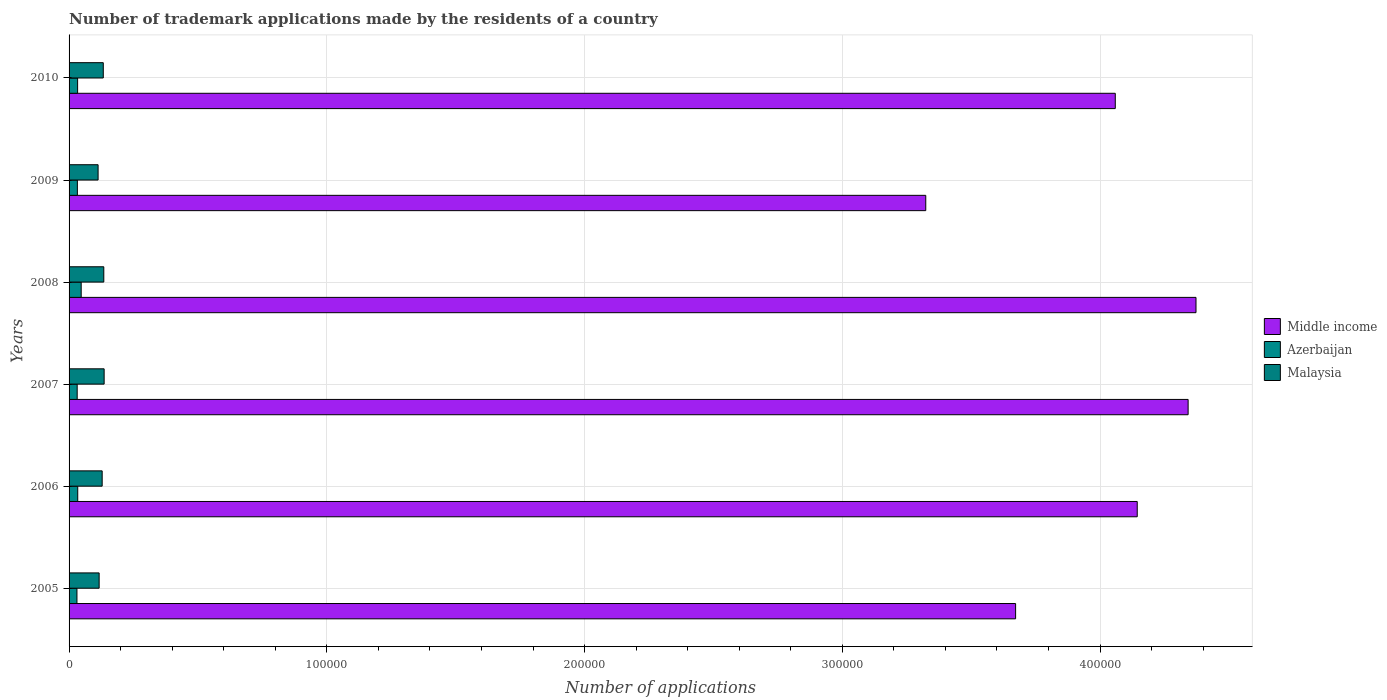How many different coloured bars are there?
Your answer should be very brief. 3. Are the number of bars per tick equal to the number of legend labels?
Ensure brevity in your answer.  Yes. How many bars are there on the 6th tick from the top?
Ensure brevity in your answer.  3. How many bars are there on the 2nd tick from the bottom?
Your response must be concise. 3. What is the label of the 1st group of bars from the top?
Keep it short and to the point. 2010. In how many cases, is the number of bars for a given year not equal to the number of legend labels?
Your answer should be very brief. 0. What is the number of trademark applications made by the residents in Middle income in 2010?
Offer a terse response. 4.06e+05. Across all years, what is the maximum number of trademark applications made by the residents in Middle income?
Keep it short and to the point. 4.37e+05. Across all years, what is the minimum number of trademark applications made by the residents in Middle income?
Your answer should be very brief. 3.32e+05. In which year was the number of trademark applications made by the residents in Middle income maximum?
Keep it short and to the point. 2008. What is the total number of trademark applications made by the residents in Middle income in the graph?
Your answer should be compact. 2.39e+06. What is the difference between the number of trademark applications made by the residents in Malaysia in 2005 and that in 2006?
Provide a succinct answer. -1172. What is the difference between the number of trademark applications made by the residents in Azerbaijan in 2005 and the number of trademark applications made by the residents in Malaysia in 2008?
Provide a succinct answer. -1.04e+04. What is the average number of trademark applications made by the residents in Malaysia per year?
Offer a very short reply. 1.27e+04. In the year 2008, what is the difference between the number of trademark applications made by the residents in Malaysia and number of trademark applications made by the residents in Azerbaijan?
Provide a short and direct response. 8771. What is the ratio of the number of trademark applications made by the residents in Middle income in 2005 to that in 2010?
Provide a short and direct response. 0.9. Is the difference between the number of trademark applications made by the residents in Malaysia in 2007 and 2010 greater than the difference between the number of trademark applications made by the residents in Azerbaijan in 2007 and 2010?
Provide a short and direct response. Yes. What is the difference between the highest and the second highest number of trademark applications made by the residents in Azerbaijan?
Give a very brief answer. 1338. What is the difference between the highest and the lowest number of trademark applications made by the residents in Malaysia?
Your answer should be compact. 2345. In how many years, is the number of trademark applications made by the residents in Azerbaijan greater than the average number of trademark applications made by the residents in Azerbaijan taken over all years?
Provide a succinct answer. 1. What does the 1st bar from the top in 2009 represents?
Provide a succinct answer. Malaysia. What does the 3rd bar from the bottom in 2007 represents?
Provide a succinct answer. Malaysia. How many bars are there?
Offer a very short reply. 18. Are all the bars in the graph horizontal?
Offer a terse response. Yes. Where does the legend appear in the graph?
Your answer should be compact. Center right. What is the title of the graph?
Provide a short and direct response. Number of trademark applications made by the residents of a country. What is the label or title of the X-axis?
Ensure brevity in your answer.  Number of applications. What is the Number of applications in Middle income in 2005?
Your response must be concise. 3.67e+05. What is the Number of applications of Azerbaijan in 2005?
Offer a terse response. 3061. What is the Number of applications in Malaysia in 2005?
Offer a terse response. 1.17e+04. What is the Number of applications of Middle income in 2006?
Make the answer very short. 4.14e+05. What is the Number of applications of Azerbaijan in 2006?
Offer a terse response. 3363. What is the Number of applications of Malaysia in 2006?
Provide a succinct answer. 1.28e+04. What is the Number of applications of Middle income in 2007?
Give a very brief answer. 4.34e+05. What is the Number of applications in Azerbaijan in 2007?
Ensure brevity in your answer.  3149. What is the Number of applications in Malaysia in 2007?
Your answer should be compact. 1.36e+04. What is the Number of applications in Middle income in 2008?
Ensure brevity in your answer.  4.37e+05. What is the Number of applications in Azerbaijan in 2008?
Give a very brief answer. 4701. What is the Number of applications in Malaysia in 2008?
Your response must be concise. 1.35e+04. What is the Number of applications in Middle income in 2009?
Offer a very short reply. 3.32e+05. What is the Number of applications of Azerbaijan in 2009?
Provide a succinct answer. 3221. What is the Number of applications in Malaysia in 2009?
Ensure brevity in your answer.  1.13e+04. What is the Number of applications of Middle income in 2010?
Offer a very short reply. 4.06e+05. What is the Number of applications in Azerbaijan in 2010?
Ensure brevity in your answer.  3310. What is the Number of applications in Malaysia in 2010?
Offer a very short reply. 1.33e+04. Across all years, what is the maximum Number of applications of Middle income?
Offer a very short reply. 4.37e+05. Across all years, what is the maximum Number of applications in Azerbaijan?
Give a very brief answer. 4701. Across all years, what is the maximum Number of applications in Malaysia?
Ensure brevity in your answer.  1.36e+04. Across all years, what is the minimum Number of applications in Middle income?
Offer a very short reply. 3.32e+05. Across all years, what is the minimum Number of applications of Azerbaijan?
Provide a short and direct response. 3061. Across all years, what is the minimum Number of applications in Malaysia?
Your answer should be compact. 1.13e+04. What is the total Number of applications in Middle income in the graph?
Your response must be concise. 2.39e+06. What is the total Number of applications in Azerbaijan in the graph?
Offer a terse response. 2.08e+04. What is the total Number of applications of Malaysia in the graph?
Provide a succinct answer. 7.61e+04. What is the difference between the Number of applications in Middle income in 2005 and that in 2006?
Ensure brevity in your answer.  -4.72e+04. What is the difference between the Number of applications in Azerbaijan in 2005 and that in 2006?
Your response must be concise. -302. What is the difference between the Number of applications of Malaysia in 2005 and that in 2006?
Offer a terse response. -1172. What is the difference between the Number of applications of Middle income in 2005 and that in 2007?
Keep it short and to the point. -6.69e+04. What is the difference between the Number of applications in Azerbaijan in 2005 and that in 2007?
Make the answer very short. -88. What is the difference between the Number of applications in Malaysia in 2005 and that in 2007?
Provide a short and direct response. -1937. What is the difference between the Number of applications in Middle income in 2005 and that in 2008?
Provide a short and direct response. -7.00e+04. What is the difference between the Number of applications of Azerbaijan in 2005 and that in 2008?
Keep it short and to the point. -1640. What is the difference between the Number of applications of Malaysia in 2005 and that in 2008?
Provide a succinct answer. -1804. What is the difference between the Number of applications of Middle income in 2005 and that in 2009?
Offer a very short reply. 3.49e+04. What is the difference between the Number of applications in Azerbaijan in 2005 and that in 2009?
Provide a short and direct response. -160. What is the difference between the Number of applications in Malaysia in 2005 and that in 2009?
Your answer should be compact. 408. What is the difference between the Number of applications in Middle income in 2005 and that in 2010?
Make the answer very short. -3.87e+04. What is the difference between the Number of applications in Azerbaijan in 2005 and that in 2010?
Make the answer very short. -249. What is the difference between the Number of applications of Malaysia in 2005 and that in 2010?
Make the answer very short. -1603. What is the difference between the Number of applications of Middle income in 2006 and that in 2007?
Provide a succinct answer. -1.97e+04. What is the difference between the Number of applications of Azerbaijan in 2006 and that in 2007?
Your answer should be compact. 214. What is the difference between the Number of applications of Malaysia in 2006 and that in 2007?
Provide a short and direct response. -765. What is the difference between the Number of applications in Middle income in 2006 and that in 2008?
Provide a succinct answer. -2.28e+04. What is the difference between the Number of applications in Azerbaijan in 2006 and that in 2008?
Provide a succinct answer. -1338. What is the difference between the Number of applications in Malaysia in 2006 and that in 2008?
Ensure brevity in your answer.  -632. What is the difference between the Number of applications in Middle income in 2006 and that in 2009?
Provide a succinct answer. 8.20e+04. What is the difference between the Number of applications of Azerbaijan in 2006 and that in 2009?
Make the answer very short. 142. What is the difference between the Number of applications in Malaysia in 2006 and that in 2009?
Offer a terse response. 1580. What is the difference between the Number of applications in Middle income in 2006 and that in 2010?
Ensure brevity in your answer.  8517. What is the difference between the Number of applications of Malaysia in 2006 and that in 2010?
Offer a very short reply. -431. What is the difference between the Number of applications in Middle income in 2007 and that in 2008?
Provide a short and direct response. -3058. What is the difference between the Number of applications of Azerbaijan in 2007 and that in 2008?
Your answer should be very brief. -1552. What is the difference between the Number of applications in Malaysia in 2007 and that in 2008?
Your answer should be compact. 133. What is the difference between the Number of applications in Middle income in 2007 and that in 2009?
Ensure brevity in your answer.  1.02e+05. What is the difference between the Number of applications in Azerbaijan in 2007 and that in 2009?
Ensure brevity in your answer.  -72. What is the difference between the Number of applications in Malaysia in 2007 and that in 2009?
Offer a very short reply. 2345. What is the difference between the Number of applications of Middle income in 2007 and that in 2010?
Provide a short and direct response. 2.83e+04. What is the difference between the Number of applications of Azerbaijan in 2007 and that in 2010?
Your answer should be compact. -161. What is the difference between the Number of applications in Malaysia in 2007 and that in 2010?
Make the answer very short. 334. What is the difference between the Number of applications in Middle income in 2008 and that in 2009?
Make the answer very short. 1.05e+05. What is the difference between the Number of applications in Azerbaijan in 2008 and that in 2009?
Provide a short and direct response. 1480. What is the difference between the Number of applications of Malaysia in 2008 and that in 2009?
Give a very brief answer. 2212. What is the difference between the Number of applications of Middle income in 2008 and that in 2010?
Your answer should be compact. 3.13e+04. What is the difference between the Number of applications of Azerbaijan in 2008 and that in 2010?
Make the answer very short. 1391. What is the difference between the Number of applications in Malaysia in 2008 and that in 2010?
Offer a terse response. 201. What is the difference between the Number of applications in Middle income in 2009 and that in 2010?
Provide a succinct answer. -7.35e+04. What is the difference between the Number of applications in Azerbaijan in 2009 and that in 2010?
Keep it short and to the point. -89. What is the difference between the Number of applications of Malaysia in 2009 and that in 2010?
Your response must be concise. -2011. What is the difference between the Number of applications of Middle income in 2005 and the Number of applications of Azerbaijan in 2006?
Keep it short and to the point. 3.64e+05. What is the difference between the Number of applications of Middle income in 2005 and the Number of applications of Malaysia in 2006?
Give a very brief answer. 3.54e+05. What is the difference between the Number of applications of Azerbaijan in 2005 and the Number of applications of Malaysia in 2006?
Your answer should be compact. -9779. What is the difference between the Number of applications of Middle income in 2005 and the Number of applications of Azerbaijan in 2007?
Provide a short and direct response. 3.64e+05. What is the difference between the Number of applications in Middle income in 2005 and the Number of applications in Malaysia in 2007?
Your answer should be very brief. 3.54e+05. What is the difference between the Number of applications of Azerbaijan in 2005 and the Number of applications of Malaysia in 2007?
Give a very brief answer. -1.05e+04. What is the difference between the Number of applications of Middle income in 2005 and the Number of applications of Azerbaijan in 2008?
Make the answer very short. 3.63e+05. What is the difference between the Number of applications in Middle income in 2005 and the Number of applications in Malaysia in 2008?
Make the answer very short. 3.54e+05. What is the difference between the Number of applications in Azerbaijan in 2005 and the Number of applications in Malaysia in 2008?
Your response must be concise. -1.04e+04. What is the difference between the Number of applications in Middle income in 2005 and the Number of applications in Azerbaijan in 2009?
Your response must be concise. 3.64e+05. What is the difference between the Number of applications in Middle income in 2005 and the Number of applications in Malaysia in 2009?
Your answer should be very brief. 3.56e+05. What is the difference between the Number of applications in Azerbaijan in 2005 and the Number of applications in Malaysia in 2009?
Keep it short and to the point. -8199. What is the difference between the Number of applications in Middle income in 2005 and the Number of applications in Azerbaijan in 2010?
Ensure brevity in your answer.  3.64e+05. What is the difference between the Number of applications of Middle income in 2005 and the Number of applications of Malaysia in 2010?
Ensure brevity in your answer.  3.54e+05. What is the difference between the Number of applications of Azerbaijan in 2005 and the Number of applications of Malaysia in 2010?
Make the answer very short. -1.02e+04. What is the difference between the Number of applications in Middle income in 2006 and the Number of applications in Azerbaijan in 2007?
Provide a short and direct response. 4.11e+05. What is the difference between the Number of applications of Middle income in 2006 and the Number of applications of Malaysia in 2007?
Provide a succinct answer. 4.01e+05. What is the difference between the Number of applications in Azerbaijan in 2006 and the Number of applications in Malaysia in 2007?
Your answer should be very brief. -1.02e+04. What is the difference between the Number of applications of Middle income in 2006 and the Number of applications of Azerbaijan in 2008?
Provide a succinct answer. 4.10e+05. What is the difference between the Number of applications of Middle income in 2006 and the Number of applications of Malaysia in 2008?
Make the answer very short. 4.01e+05. What is the difference between the Number of applications of Azerbaijan in 2006 and the Number of applications of Malaysia in 2008?
Keep it short and to the point. -1.01e+04. What is the difference between the Number of applications in Middle income in 2006 and the Number of applications in Azerbaijan in 2009?
Provide a succinct answer. 4.11e+05. What is the difference between the Number of applications in Middle income in 2006 and the Number of applications in Malaysia in 2009?
Offer a very short reply. 4.03e+05. What is the difference between the Number of applications in Azerbaijan in 2006 and the Number of applications in Malaysia in 2009?
Make the answer very short. -7897. What is the difference between the Number of applications of Middle income in 2006 and the Number of applications of Azerbaijan in 2010?
Provide a short and direct response. 4.11e+05. What is the difference between the Number of applications of Middle income in 2006 and the Number of applications of Malaysia in 2010?
Make the answer very short. 4.01e+05. What is the difference between the Number of applications in Azerbaijan in 2006 and the Number of applications in Malaysia in 2010?
Keep it short and to the point. -9908. What is the difference between the Number of applications of Middle income in 2007 and the Number of applications of Azerbaijan in 2008?
Provide a succinct answer. 4.29e+05. What is the difference between the Number of applications of Middle income in 2007 and the Number of applications of Malaysia in 2008?
Give a very brief answer. 4.21e+05. What is the difference between the Number of applications of Azerbaijan in 2007 and the Number of applications of Malaysia in 2008?
Ensure brevity in your answer.  -1.03e+04. What is the difference between the Number of applications of Middle income in 2007 and the Number of applications of Azerbaijan in 2009?
Give a very brief answer. 4.31e+05. What is the difference between the Number of applications in Middle income in 2007 and the Number of applications in Malaysia in 2009?
Provide a short and direct response. 4.23e+05. What is the difference between the Number of applications of Azerbaijan in 2007 and the Number of applications of Malaysia in 2009?
Offer a very short reply. -8111. What is the difference between the Number of applications in Middle income in 2007 and the Number of applications in Azerbaijan in 2010?
Keep it short and to the point. 4.31e+05. What is the difference between the Number of applications of Middle income in 2007 and the Number of applications of Malaysia in 2010?
Keep it short and to the point. 4.21e+05. What is the difference between the Number of applications in Azerbaijan in 2007 and the Number of applications in Malaysia in 2010?
Provide a succinct answer. -1.01e+04. What is the difference between the Number of applications of Middle income in 2008 and the Number of applications of Azerbaijan in 2009?
Your response must be concise. 4.34e+05. What is the difference between the Number of applications in Middle income in 2008 and the Number of applications in Malaysia in 2009?
Your answer should be compact. 4.26e+05. What is the difference between the Number of applications of Azerbaijan in 2008 and the Number of applications of Malaysia in 2009?
Your answer should be very brief. -6559. What is the difference between the Number of applications in Middle income in 2008 and the Number of applications in Azerbaijan in 2010?
Provide a short and direct response. 4.34e+05. What is the difference between the Number of applications in Middle income in 2008 and the Number of applications in Malaysia in 2010?
Offer a very short reply. 4.24e+05. What is the difference between the Number of applications in Azerbaijan in 2008 and the Number of applications in Malaysia in 2010?
Give a very brief answer. -8570. What is the difference between the Number of applications in Middle income in 2009 and the Number of applications in Azerbaijan in 2010?
Offer a terse response. 3.29e+05. What is the difference between the Number of applications of Middle income in 2009 and the Number of applications of Malaysia in 2010?
Give a very brief answer. 3.19e+05. What is the difference between the Number of applications of Azerbaijan in 2009 and the Number of applications of Malaysia in 2010?
Offer a terse response. -1.00e+04. What is the average Number of applications in Middle income per year?
Keep it short and to the point. 3.99e+05. What is the average Number of applications of Azerbaijan per year?
Your answer should be compact. 3467.5. What is the average Number of applications of Malaysia per year?
Give a very brief answer. 1.27e+04. In the year 2005, what is the difference between the Number of applications of Middle income and Number of applications of Azerbaijan?
Your response must be concise. 3.64e+05. In the year 2005, what is the difference between the Number of applications of Middle income and Number of applications of Malaysia?
Offer a terse response. 3.56e+05. In the year 2005, what is the difference between the Number of applications in Azerbaijan and Number of applications in Malaysia?
Provide a succinct answer. -8607. In the year 2006, what is the difference between the Number of applications of Middle income and Number of applications of Azerbaijan?
Ensure brevity in your answer.  4.11e+05. In the year 2006, what is the difference between the Number of applications of Middle income and Number of applications of Malaysia?
Provide a succinct answer. 4.02e+05. In the year 2006, what is the difference between the Number of applications in Azerbaijan and Number of applications in Malaysia?
Your answer should be compact. -9477. In the year 2007, what is the difference between the Number of applications of Middle income and Number of applications of Azerbaijan?
Ensure brevity in your answer.  4.31e+05. In the year 2007, what is the difference between the Number of applications in Middle income and Number of applications in Malaysia?
Provide a succinct answer. 4.21e+05. In the year 2007, what is the difference between the Number of applications of Azerbaijan and Number of applications of Malaysia?
Give a very brief answer. -1.05e+04. In the year 2008, what is the difference between the Number of applications of Middle income and Number of applications of Azerbaijan?
Your response must be concise. 4.33e+05. In the year 2008, what is the difference between the Number of applications in Middle income and Number of applications in Malaysia?
Ensure brevity in your answer.  4.24e+05. In the year 2008, what is the difference between the Number of applications of Azerbaijan and Number of applications of Malaysia?
Ensure brevity in your answer.  -8771. In the year 2009, what is the difference between the Number of applications of Middle income and Number of applications of Azerbaijan?
Keep it short and to the point. 3.29e+05. In the year 2009, what is the difference between the Number of applications in Middle income and Number of applications in Malaysia?
Ensure brevity in your answer.  3.21e+05. In the year 2009, what is the difference between the Number of applications in Azerbaijan and Number of applications in Malaysia?
Keep it short and to the point. -8039. In the year 2010, what is the difference between the Number of applications of Middle income and Number of applications of Azerbaijan?
Make the answer very short. 4.03e+05. In the year 2010, what is the difference between the Number of applications in Middle income and Number of applications in Malaysia?
Your answer should be very brief. 3.93e+05. In the year 2010, what is the difference between the Number of applications of Azerbaijan and Number of applications of Malaysia?
Make the answer very short. -9961. What is the ratio of the Number of applications in Middle income in 2005 to that in 2006?
Your response must be concise. 0.89. What is the ratio of the Number of applications in Azerbaijan in 2005 to that in 2006?
Offer a terse response. 0.91. What is the ratio of the Number of applications of Malaysia in 2005 to that in 2006?
Offer a very short reply. 0.91. What is the ratio of the Number of applications of Middle income in 2005 to that in 2007?
Offer a terse response. 0.85. What is the ratio of the Number of applications in Azerbaijan in 2005 to that in 2007?
Give a very brief answer. 0.97. What is the ratio of the Number of applications in Malaysia in 2005 to that in 2007?
Give a very brief answer. 0.86. What is the ratio of the Number of applications of Middle income in 2005 to that in 2008?
Offer a very short reply. 0.84. What is the ratio of the Number of applications in Azerbaijan in 2005 to that in 2008?
Provide a succinct answer. 0.65. What is the ratio of the Number of applications of Malaysia in 2005 to that in 2008?
Provide a short and direct response. 0.87. What is the ratio of the Number of applications in Middle income in 2005 to that in 2009?
Your response must be concise. 1.1. What is the ratio of the Number of applications in Azerbaijan in 2005 to that in 2009?
Give a very brief answer. 0.95. What is the ratio of the Number of applications of Malaysia in 2005 to that in 2009?
Your answer should be very brief. 1.04. What is the ratio of the Number of applications in Middle income in 2005 to that in 2010?
Your response must be concise. 0.9. What is the ratio of the Number of applications in Azerbaijan in 2005 to that in 2010?
Make the answer very short. 0.92. What is the ratio of the Number of applications in Malaysia in 2005 to that in 2010?
Your answer should be compact. 0.88. What is the ratio of the Number of applications of Middle income in 2006 to that in 2007?
Your answer should be compact. 0.95. What is the ratio of the Number of applications of Azerbaijan in 2006 to that in 2007?
Provide a short and direct response. 1.07. What is the ratio of the Number of applications in Malaysia in 2006 to that in 2007?
Your response must be concise. 0.94. What is the ratio of the Number of applications of Middle income in 2006 to that in 2008?
Offer a terse response. 0.95. What is the ratio of the Number of applications in Azerbaijan in 2006 to that in 2008?
Offer a very short reply. 0.72. What is the ratio of the Number of applications of Malaysia in 2006 to that in 2008?
Offer a terse response. 0.95. What is the ratio of the Number of applications in Middle income in 2006 to that in 2009?
Your answer should be very brief. 1.25. What is the ratio of the Number of applications in Azerbaijan in 2006 to that in 2009?
Provide a succinct answer. 1.04. What is the ratio of the Number of applications in Malaysia in 2006 to that in 2009?
Provide a short and direct response. 1.14. What is the ratio of the Number of applications in Middle income in 2006 to that in 2010?
Your answer should be very brief. 1.02. What is the ratio of the Number of applications in Malaysia in 2006 to that in 2010?
Offer a very short reply. 0.97. What is the ratio of the Number of applications in Middle income in 2007 to that in 2008?
Your response must be concise. 0.99. What is the ratio of the Number of applications of Azerbaijan in 2007 to that in 2008?
Provide a short and direct response. 0.67. What is the ratio of the Number of applications of Malaysia in 2007 to that in 2008?
Your answer should be compact. 1.01. What is the ratio of the Number of applications in Middle income in 2007 to that in 2009?
Provide a short and direct response. 1.31. What is the ratio of the Number of applications in Azerbaijan in 2007 to that in 2009?
Your answer should be compact. 0.98. What is the ratio of the Number of applications of Malaysia in 2007 to that in 2009?
Provide a succinct answer. 1.21. What is the ratio of the Number of applications in Middle income in 2007 to that in 2010?
Your answer should be very brief. 1.07. What is the ratio of the Number of applications in Azerbaijan in 2007 to that in 2010?
Your answer should be very brief. 0.95. What is the ratio of the Number of applications of Malaysia in 2007 to that in 2010?
Keep it short and to the point. 1.03. What is the ratio of the Number of applications in Middle income in 2008 to that in 2009?
Ensure brevity in your answer.  1.32. What is the ratio of the Number of applications of Azerbaijan in 2008 to that in 2009?
Your answer should be compact. 1.46. What is the ratio of the Number of applications of Malaysia in 2008 to that in 2009?
Make the answer very short. 1.2. What is the ratio of the Number of applications of Middle income in 2008 to that in 2010?
Your response must be concise. 1.08. What is the ratio of the Number of applications in Azerbaijan in 2008 to that in 2010?
Your response must be concise. 1.42. What is the ratio of the Number of applications in Malaysia in 2008 to that in 2010?
Provide a succinct answer. 1.02. What is the ratio of the Number of applications in Middle income in 2009 to that in 2010?
Make the answer very short. 0.82. What is the ratio of the Number of applications of Azerbaijan in 2009 to that in 2010?
Offer a terse response. 0.97. What is the ratio of the Number of applications in Malaysia in 2009 to that in 2010?
Give a very brief answer. 0.85. What is the difference between the highest and the second highest Number of applications in Middle income?
Keep it short and to the point. 3058. What is the difference between the highest and the second highest Number of applications of Azerbaijan?
Your answer should be very brief. 1338. What is the difference between the highest and the second highest Number of applications in Malaysia?
Make the answer very short. 133. What is the difference between the highest and the lowest Number of applications of Middle income?
Your response must be concise. 1.05e+05. What is the difference between the highest and the lowest Number of applications in Azerbaijan?
Keep it short and to the point. 1640. What is the difference between the highest and the lowest Number of applications in Malaysia?
Make the answer very short. 2345. 